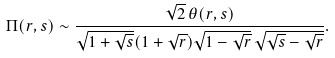<formula> <loc_0><loc_0><loc_500><loc_500>\Pi ( r , s ) \sim \frac { \sqrt { 2 } \, \theta ( r , s ) } { \sqrt { 1 + \sqrt { s } } ( 1 + \sqrt { r } ) \sqrt { 1 - \sqrt { r } } \, \sqrt { \sqrt { s } - \sqrt { r } } } .</formula> 